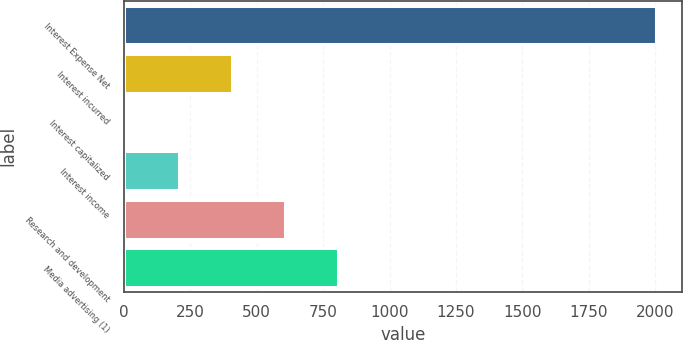Convert chart to OTSL. <chart><loc_0><loc_0><loc_500><loc_500><bar_chart><fcel>Interest Expense Net<fcel>Interest incurred<fcel>Interest capitalized<fcel>Interest income<fcel>Research and development<fcel>Media advertising (1)<nl><fcel>2002<fcel>406.32<fcel>7.4<fcel>206.86<fcel>605.78<fcel>805.24<nl></chart> 